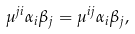<formula> <loc_0><loc_0><loc_500><loc_500>\mu ^ { j i } \alpha _ { i } \beta _ { j } = \mu ^ { i j } \alpha _ { i } \beta _ { j } ,</formula> 